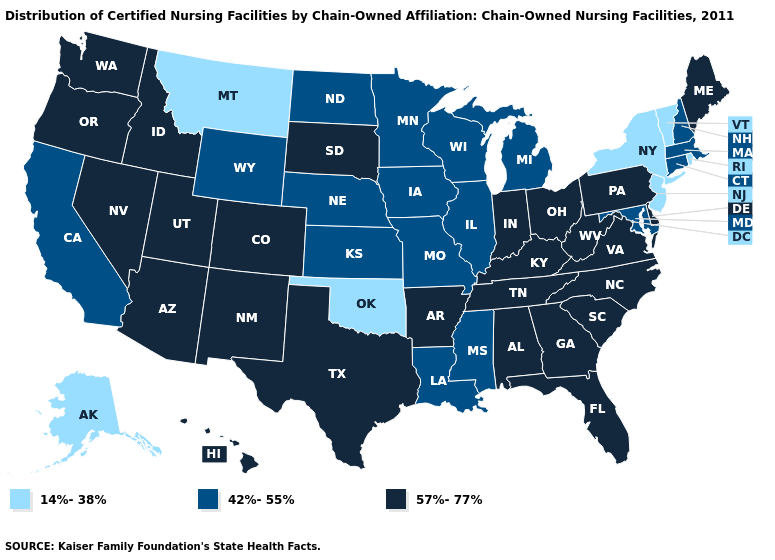Name the states that have a value in the range 42%-55%?
Answer briefly. California, Connecticut, Illinois, Iowa, Kansas, Louisiana, Maryland, Massachusetts, Michigan, Minnesota, Mississippi, Missouri, Nebraska, New Hampshire, North Dakota, Wisconsin, Wyoming. Among the states that border West Virginia , does Virginia have the lowest value?
Be succinct. No. How many symbols are there in the legend?
Be succinct. 3. Which states hav the highest value in the South?
Be succinct. Alabama, Arkansas, Delaware, Florida, Georgia, Kentucky, North Carolina, South Carolina, Tennessee, Texas, Virginia, West Virginia. What is the lowest value in the USA?
Concise answer only. 14%-38%. Among the states that border New Mexico , which have the highest value?
Quick response, please. Arizona, Colorado, Texas, Utah. What is the value of Massachusetts?
Be succinct. 42%-55%. Which states have the highest value in the USA?
Give a very brief answer. Alabama, Arizona, Arkansas, Colorado, Delaware, Florida, Georgia, Hawaii, Idaho, Indiana, Kentucky, Maine, Nevada, New Mexico, North Carolina, Ohio, Oregon, Pennsylvania, South Carolina, South Dakota, Tennessee, Texas, Utah, Virginia, Washington, West Virginia. Which states have the highest value in the USA?
Be succinct. Alabama, Arizona, Arkansas, Colorado, Delaware, Florida, Georgia, Hawaii, Idaho, Indiana, Kentucky, Maine, Nevada, New Mexico, North Carolina, Ohio, Oregon, Pennsylvania, South Carolina, South Dakota, Tennessee, Texas, Utah, Virginia, Washington, West Virginia. Does the first symbol in the legend represent the smallest category?
Short answer required. Yes. What is the lowest value in states that border Ohio?
Write a very short answer. 42%-55%. What is the lowest value in the West?
Answer briefly. 14%-38%. What is the highest value in the USA?
Quick response, please. 57%-77%. Among the states that border Maryland , which have the highest value?
Quick response, please. Delaware, Pennsylvania, Virginia, West Virginia. Name the states that have a value in the range 57%-77%?
Short answer required. Alabama, Arizona, Arkansas, Colorado, Delaware, Florida, Georgia, Hawaii, Idaho, Indiana, Kentucky, Maine, Nevada, New Mexico, North Carolina, Ohio, Oregon, Pennsylvania, South Carolina, South Dakota, Tennessee, Texas, Utah, Virginia, Washington, West Virginia. 